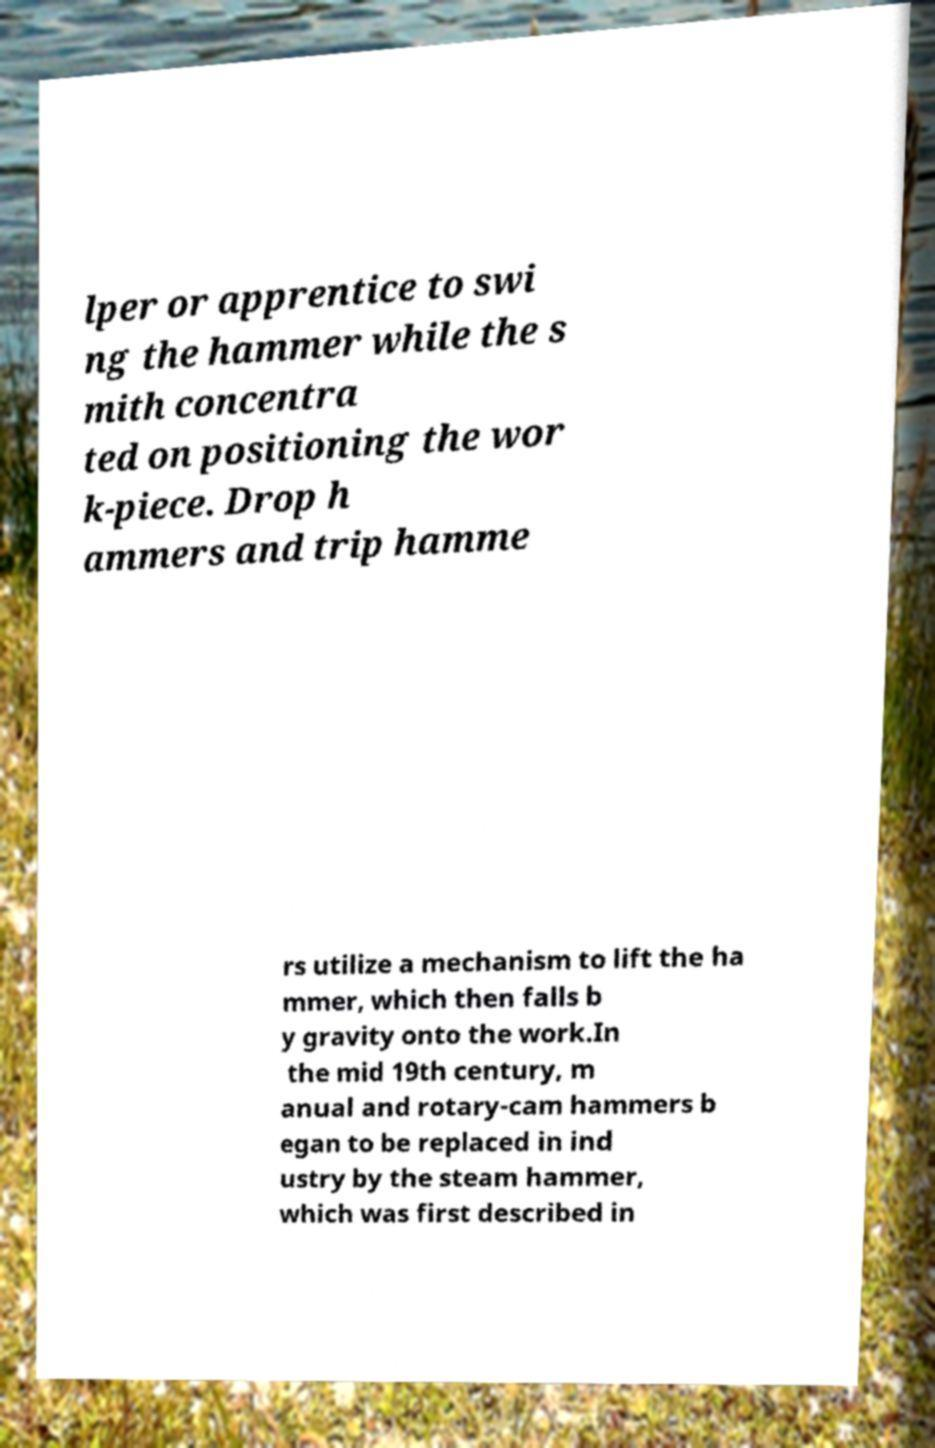Could you assist in decoding the text presented in this image and type it out clearly? lper or apprentice to swi ng the hammer while the s mith concentra ted on positioning the wor k-piece. Drop h ammers and trip hamme rs utilize a mechanism to lift the ha mmer, which then falls b y gravity onto the work.In the mid 19th century, m anual and rotary-cam hammers b egan to be replaced in ind ustry by the steam hammer, which was first described in 